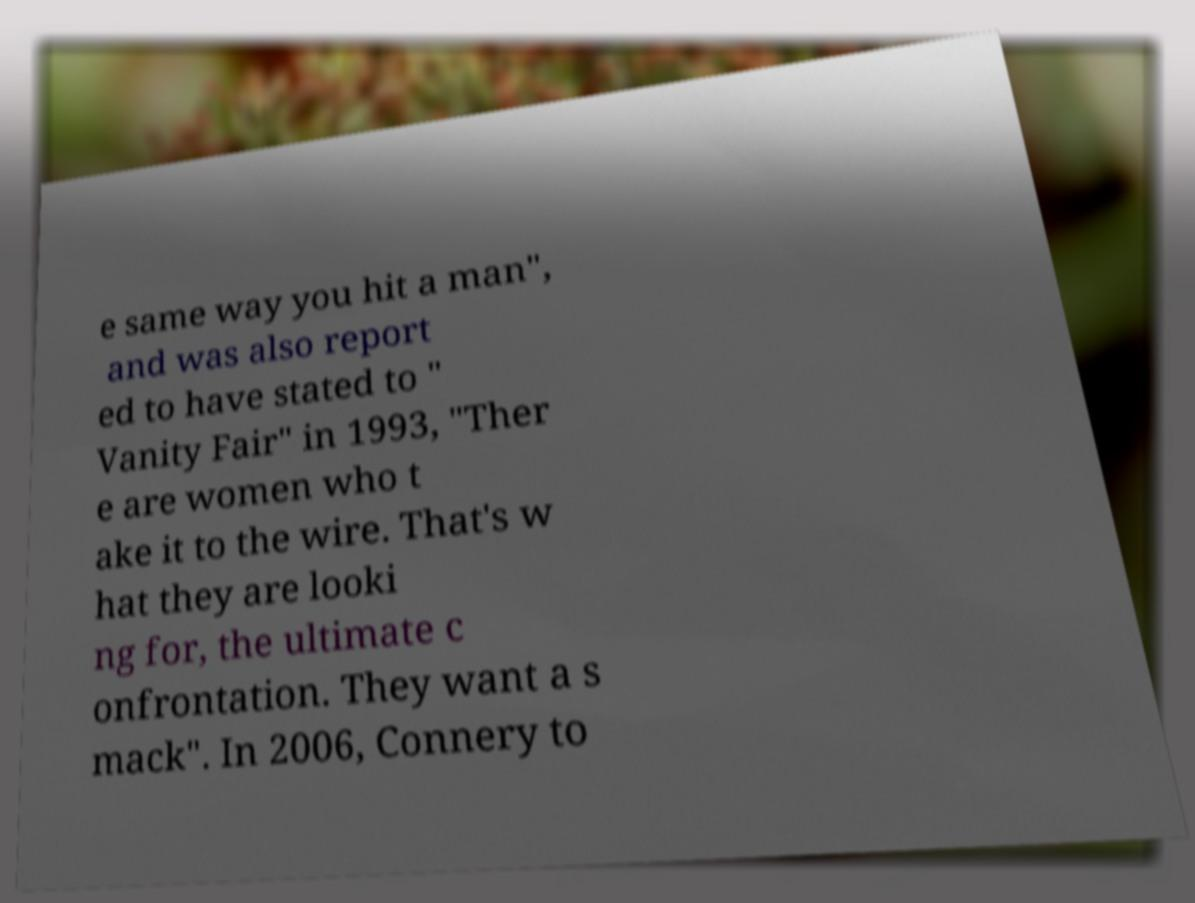There's text embedded in this image that I need extracted. Can you transcribe it verbatim? e same way you hit a man", and was also report ed to have stated to " Vanity Fair" in 1993, "Ther e are women who t ake it to the wire. That's w hat they are looki ng for, the ultimate c onfrontation. They want a s mack". In 2006, Connery to 